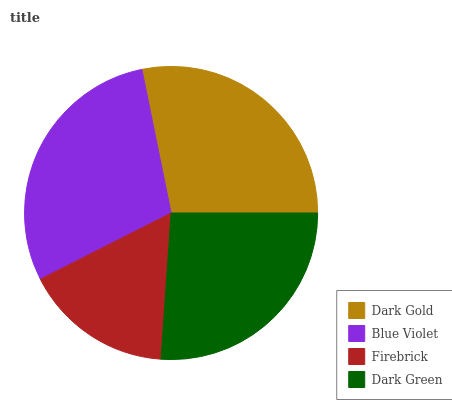Is Firebrick the minimum?
Answer yes or no. Yes. Is Blue Violet the maximum?
Answer yes or no. Yes. Is Blue Violet the minimum?
Answer yes or no. No. Is Firebrick the maximum?
Answer yes or no. No. Is Blue Violet greater than Firebrick?
Answer yes or no. Yes. Is Firebrick less than Blue Violet?
Answer yes or no. Yes. Is Firebrick greater than Blue Violet?
Answer yes or no. No. Is Blue Violet less than Firebrick?
Answer yes or no. No. Is Dark Gold the high median?
Answer yes or no. Yes. Is Dark Green the low median?
Answer yes or no. Yes. Is Firebrick the high median?
Answer yes or no. No. Is Blue Violet the low median?
Answer yes or no. No. 